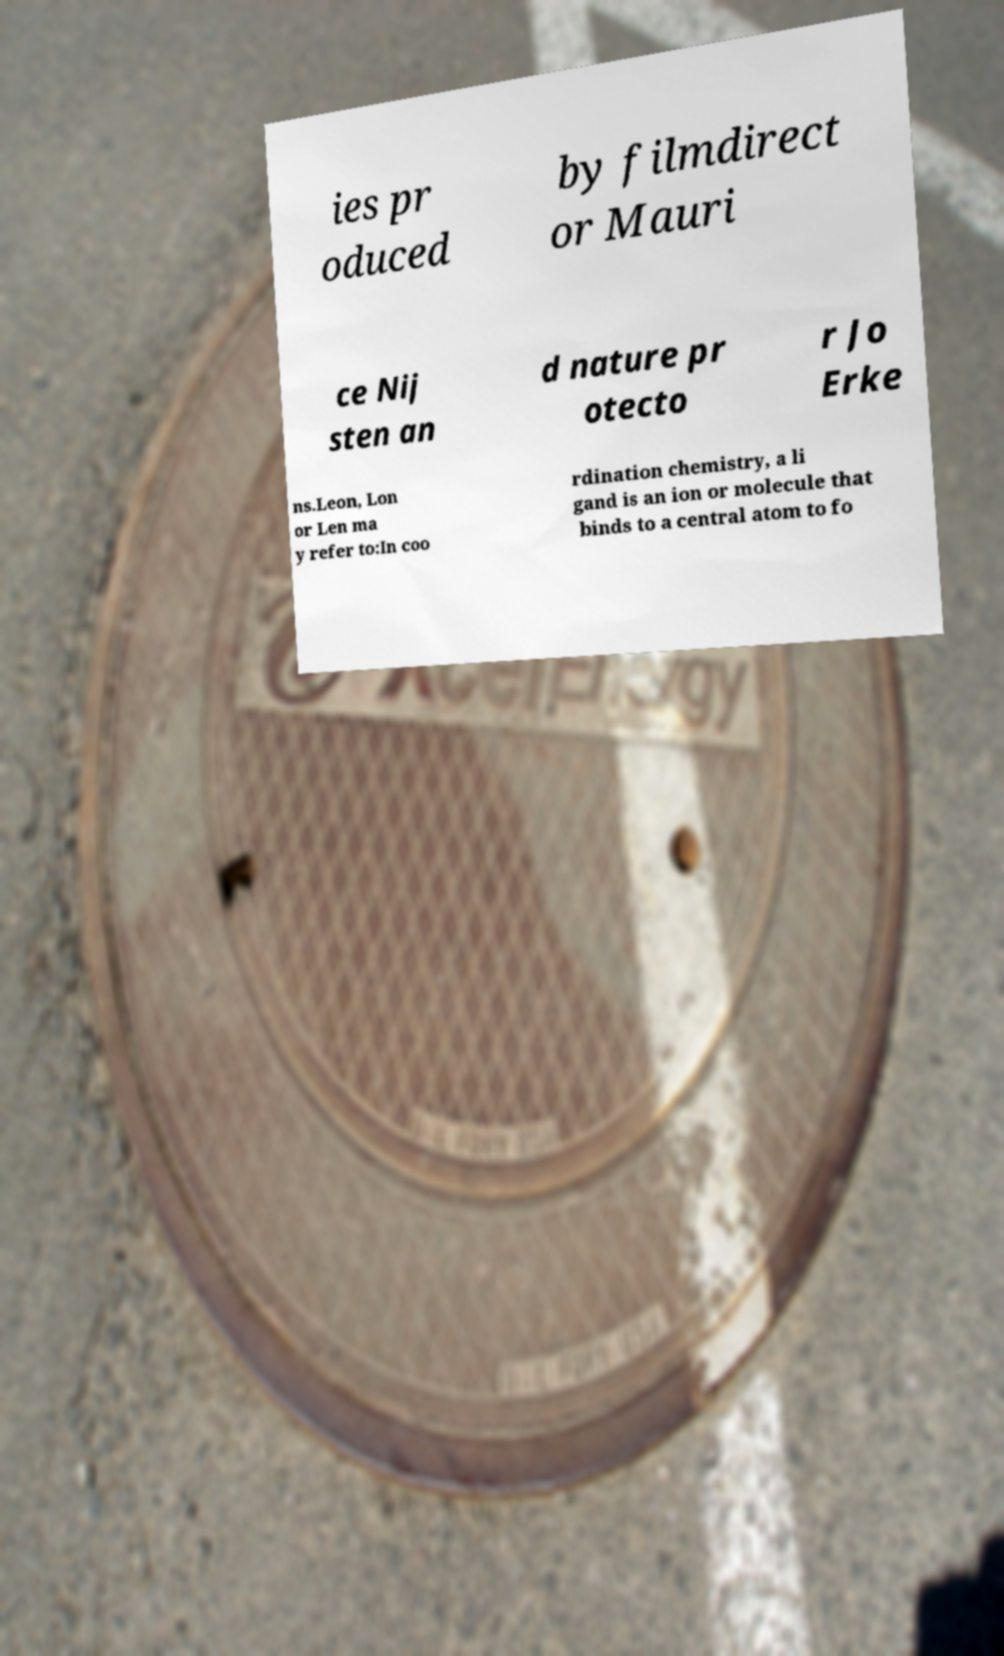Could you extract and type out the text from this image? ies pr oduced by filmdirect or Mauri ce Nij sten an d nature pr otecto r Jo Erke ns.Leon, Lon or Len ma y refer to:In coo rdination chemistry, a li gand is an ion or molecule that binds to a central atom to fo 